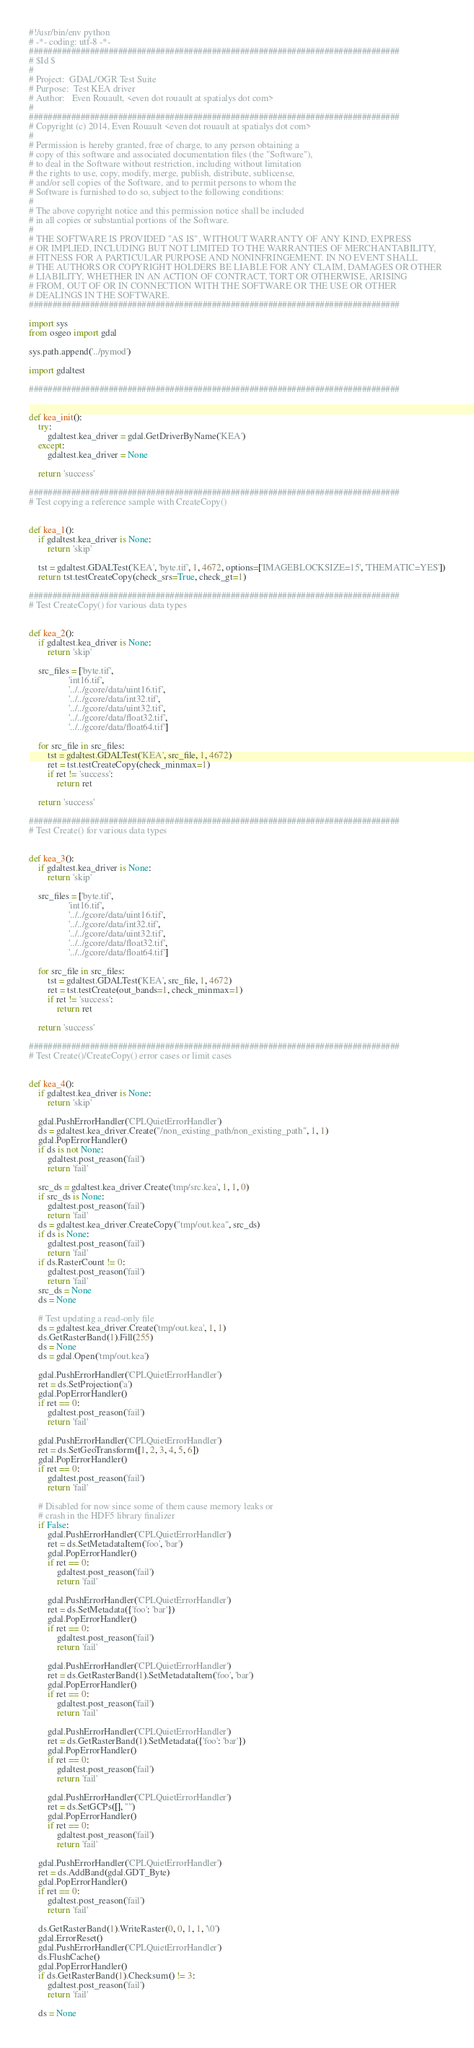<code> <loc_0><loc_0><loc_500><loc_500><_Python_>#!/usr/bin/env python
# -*- coding: utf-8 -*-
###############################################################################
# $Id $
#
# Project:  GDAL/OGR Test Suite
# Purpose:  Test KEA driver
# Author:   Even Rouault, <even dot rouault at spatialys dot com>
#
###############################################################################
# Copyright (c) 2014, Even Rouault <even dot rouault at spatialys dot com>
#
# Permission is hereby granted, free of charge, to any person obtaining a
# copy of this software and associated documentation files (the "Software"),
# to deal in the Software without restriction, including without limitation
# the rights to use, copy, modify, merge, publish, distribute, sublicense,
# and/or sell copies of the Software, and to permit persons to whom the
# Software is furnished to do so, subject to the following conditions:
#
# The above copyright notice and this permission notice shall be included
# in all copies or substantial portions of the Software.
#
# THE SOFTWARE IS PROVIDED "AS IS", WITHOUT WARRANTY OF ANY KIND, EXPRESS
# OR IMPLIED, INCLUDING BUT NOT LIMITED TO THE WARRANTIES OF MERCHANTABILITY,
# FITNESS FOR A PARTICULAR PURPOSE AND NONINFRINGEMENT. IN NO EVENT SHALL
# THE AUTHORS OR COPYRIGHT HOLDERS BE LIABLE FOR ANY CLAIM, DAMAGES OR OTHER
# LIABILITY, WHETHER IN AN ACTION OF CONTRACT, TORT OR OTHERWISE, ARISING
# FROM, OUT OF OR IN CONNECTION WITH THE SOFTWARE OR THE USE OR OTHER
# DEALINGS IN THE SOFTWARE.
###############################################################################

import sys
from osgeo import gdal

sys.path.append('../pymod')

import gdaltest

###############################################################################


def kea_init():
    try:
        gdaltest.kea_driver = gdal.GetDriverByName('KEA')
    except:
        gdaltest.kea_driver = None

    return 'success'

###############################################################################
# Test copying a reference sample with CreateCopy()


def kea_1():
    if gdaltest.kea_driver is None:
        return 'skip'

    tst = gdaltest.GDALTest('KEA', 'byte.tif', 1, 4672, options=['IMAGEBLOCKSIZE=15', 'THEMATIC=YES'])
    return tst.testCreateCopy(check_srs=True, check_gt=1)

###############################################################################
# Test CreateCopy() for various data types


def kea_2():
    if gdaltest.kea_driver is None:
        return 'skip'

    src_files = ['byte.tif',
                 'int16.tif',
                 '../../gcore/data/uint16.tif',
                 '../../gcore/data/int32.tif',
                 '../../gcore/data/uint32.tif',
                 '../../gcore/data/float32.tif',
                 '../../gcore/data/float64.tif']

    for src_file in src_files:
        tst = gdaltest.GDALTest('KEA', src_file, 1, 4672)
        ret = tst.testCreateCopy(check_minmax=1)
        if ret != 'success':
            return ret

    return 'success'

###############################################################################
# Test Create() for various data types


def kea_3():
    if gdaltest.kea_driver is None:
        return 'skip'

    src_files = ['byte.tif',
                 'int16.tif',
                 '../../gcore/data/uint16.tif',
                 '../../gcore/data/int32.tif',
                 '../../gcore/data/uint32.tif',
                 '../../gcore/data/float32.tif',
                 '../../gcore/data/float64.tif']

    for src_file in src_files:
        tst = gdaltest.GDALTest('KEA', src_file, 1, 4672)
        ret = tst.testCreate(out_bands=1, check_minmax=1)
        if ret != 'success':
            return ret

    return 'success'

###############################################################################
# Test Create()/CreateCopy() error cases or limit cases


def kea_4():
    if gdaltest.kea_driver is None:
        return 'skip'

    gdal.PushErrorHandler('CPLQuietErrorHandler')
    ds = gdaltest.kea_driver.Create("/non_existing_path/non_existing_path", 1, 1)
    gdal.PopErrorHandler()
    if ds is not None:
        gdaltest.post_reason('fail')
        return 'fail'

    src_ds = gdaltest.kea_driver.Create('tmp/src.kea', 1, 1, 0)
    if src_ds is None:
        gdaltest.post_reason('fail')
        return 'fail'
    ds = gdaltest.kea_driver.CreateCopy("tmp/out.kea", src_ds)
    if ds is None:
        gdaltest.post_reason('fail')
        return 'fail'
    if ds.RasterCount != 0:
        gdaltest.post_reason('fail')
        return 'fail'
    src_ds = None
    ds = None

    # Test updating a read-only file
    ds = gdaltest.kea_driver.Create('tmp/out.kea', 1, 1)
    ds.GetRasterBand(1).Fill(255)
    ds = None
    ds = gdal.Open('tmp/out.kea')

    gdal.PushErrorHandler('CPLQuietErrorHandler')
    ret = ds.SetProjection('a')
    gdal.PopErrorHandler()
    if ret == 0:
        gdaltest.post_reason('fail')
        return 'fail'

    gdal.PushErrorHandler('CPLQuietErrorHandler')
    ret = ds.SetGeoTransform([1, 2, 3, 4, 5, 6])
    gdal.PopErrorHandler()
    if ret == 0:
        gdaltest.post_reason('fail')
        return 'fail'

    # Disabled for now since some of them cause memory leaks or
    # crash in the HDF5 library finalizer
    if False:
        gdal.PushErrorHandler('CPLQuietErrorHandler')
        ret = ds.SetMetadataItem('foo', 'bar')
        gdal.PopErrorHandler()
        if ret == 0:
            gdaltest.post_reason('fail')
            return 'fail'

        gdal.PushErrorHandler('CPLQuietErrorHandler')
        ret = ds.SetMetadata({'foo': 'bar'})
        gdal.PopErrorHandler()
        if ret == 0:
            gdaltest.post_reason('fail')
            return 'fail'

        gdal.PushErrorHandler('CPLQuietErrorHandler')
        ret = ds.GetRasterBand(1).SetMetadataItem('foo', 'bar')
        gdal.PopErrorHandler()
        if ret == 0:
            gdaltest.post_reason('fail')
            return 'fail'

        gdal.PushErrorHandler('CPLQuietErrorHandler')
        ret = ds.GetRasterBand(1).SetMetadata({'foo': 'bar'})
        gdal.PopErrorHandler()
        if ret == 0:
            gdaltest.post_reason('fail')
            return 'fail'

        gdal.PushErrorHandler('CPLQuietErrorHandler')
        ret = ds.SetGCPs([], "")
        gdal.PopErrorHandler()
        if ret == 0:
            gdaltest.post_reason('fail')
            return 'fail'

    gdal.PushErrorHandler('CPLQuietErrorHandler')
    ret = ds.AddBand(gdal.GDT_Byte)
    gdal.PopErrorHandler()
    if ret == 0:
        gdaltest.post_reason('fail')
        return 'fail'

    ds.GetRasterBand(1).WriteRaster(0, 0, 1, 1, '\0')
    gdal.ErrorReset()
    gdal.PushErrorHandler('CPLQuietErrorHandler')
    ds.FlushCache()
    gdal.PopErrorHandler()
    if ds.GetRasterBand(1).Checksum() != 3:
        gdaltest.post_reason('fail')
        return 'fail'

    ds = None
</code> 